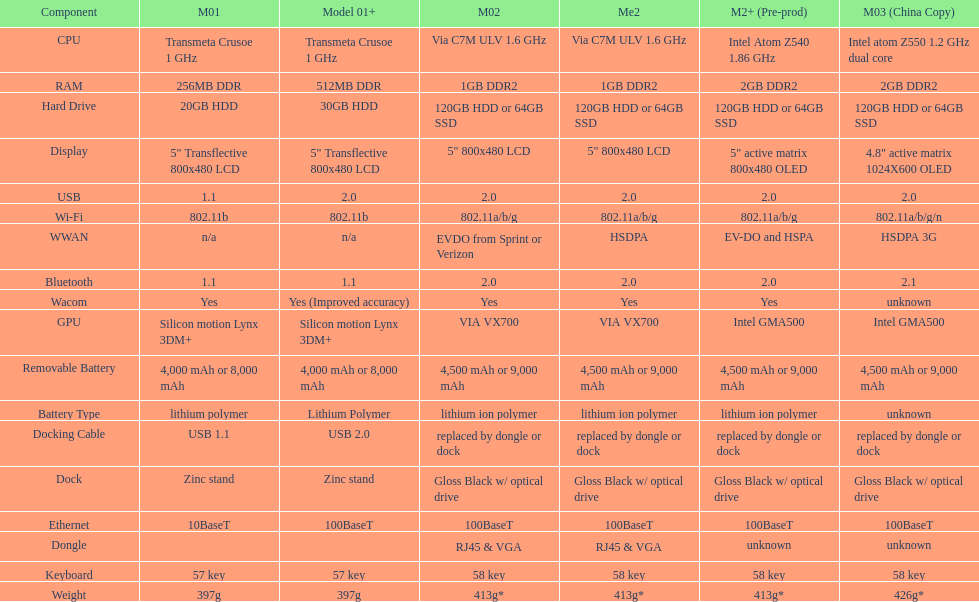How many models have 1.6ghz? 2. 